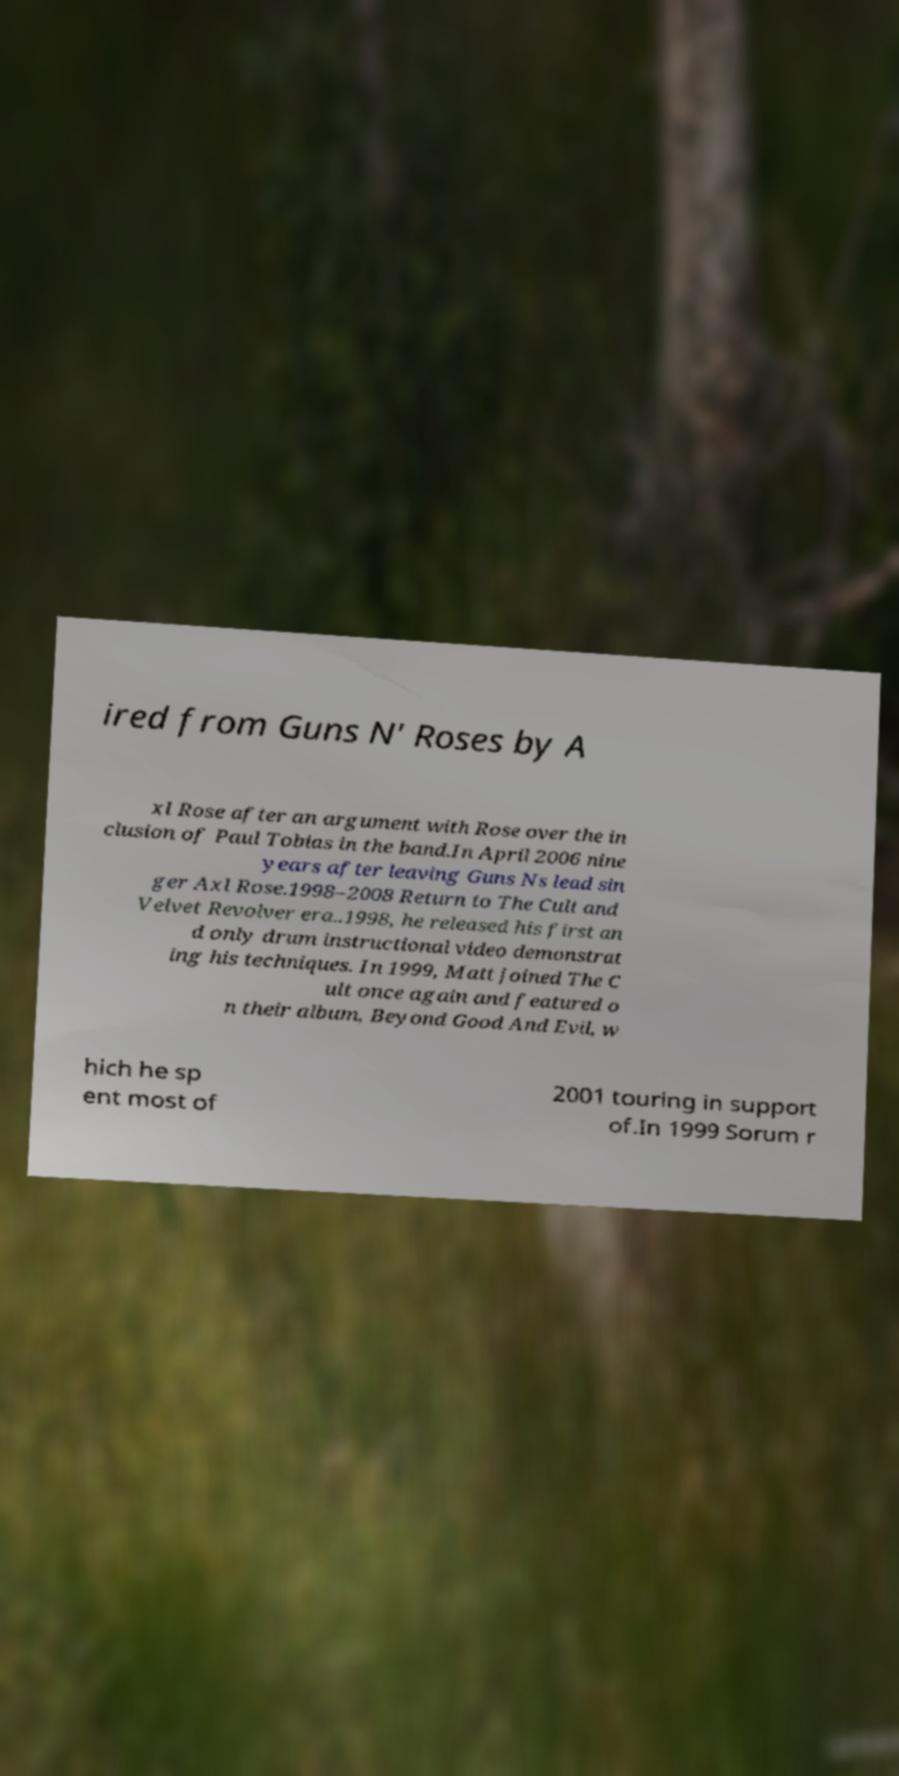What messages or text are displayed in this image? I need them in a readable, typed format. ired from Guns N' Roses by A xl Rose after an argument with Rose over the in clusion of Paul Tobias in the band.In April 2006 nine years after leaving Guns Ns lead sin ger Axl Rose.1998–2008 Return to The Cult and Velvet Revolver era..1998, he released his first an d only drum instructional video demonstrat ing his techniques. In 1999, Matt joined The C ult once again and featured o n their album, Beyond Good And Evil, w hich he sp ent most of 2001 touring in support of.In 1999 Sorum r 